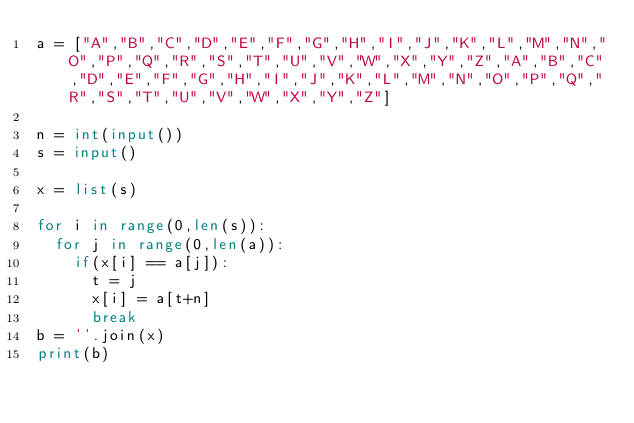Convert code to text. <code><loc_0><loc_0><loc_500><loc_500><_Python_>a = ["A","B","C","D","E","F","G","H","I","J","K","L","M","N","O","P","Q","R","S","T","U","V","W","X","Y","Z","A","B","C","D","E","F","G","H","I","J","K","L","M","N","O","P","Q","R","S","T","U","V","W","X","Y","Z"]

n = int(input())
s = input()

x = list(s)

for i in range(0,len(s)):
  for j in range(0,len(a)):
    if(x[i] == a[j]):
      t = j
      x[i] = a[t+n]
      break
b = ''.join(x)
print(b)</code> 